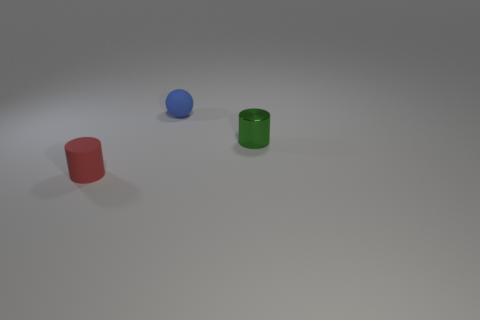Add 1 tiny green shiny things. How many objects exist? 4 Subtract 1 green cylinders. How many objects are left? 2 Subtract all balls. How many objects are left? 2 Subtract all rubber things. Subtract all big cyan metal things. How many objects are left? 1 Add 1 red rubber things. How many red rubber things are left? 2 Add 3 tiny matte spheres. How many tiny matte spheres exist? 4 